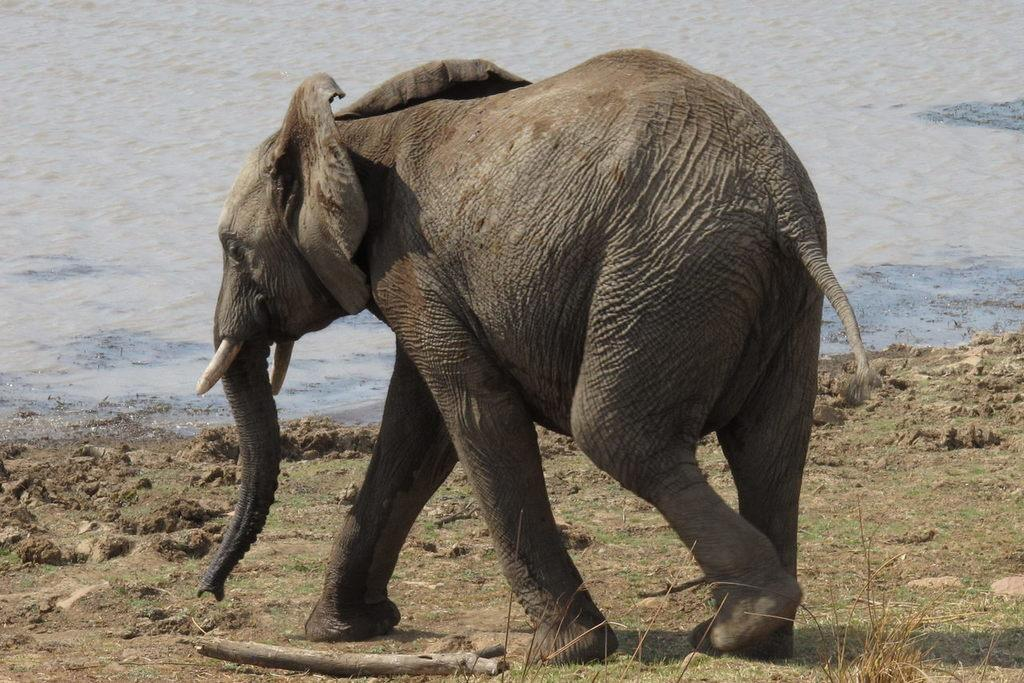What animal is present in the image? There is an elephant in the image. What can be seen in the background of the image? There is water visible in the background of the image. What type of vegetation is on the ground in the image? There is grass on the ground in the image. What type of object is on the ground in the image? There is a wooden object on the ground in the image. What grade is the elephant in the image? The image does not indicate any grade or educational level for the elephant, as it is a photograph and not a school setting. 